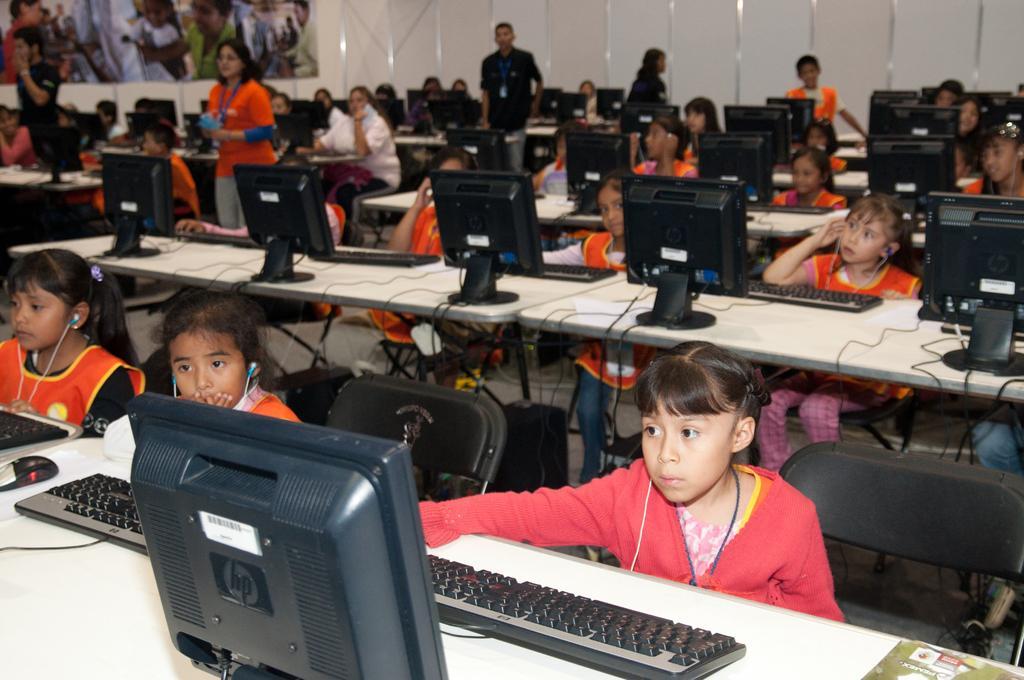Please provide a concise description of this image. There is a group of people. They are sitting on a chairs. They are wearing headphones. Some persons are standing. They are wearing id card. There is a table. There is a laptop,keyboard,mouse,paper on a table. We can see in the background poster and wall. 